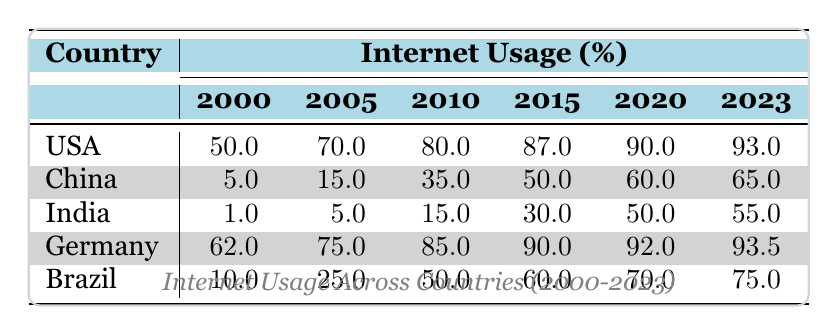What was the internet usage percentage in Germany in 2010? The table shows that in 2010, the internet usage in Germany was 85.0%.
Answer: 85.0 Which country had the highest internet usage in 2023? In 2023, the USA had the highest internet usage at 93.0%.
Answer: USA What is the difference in internet usage between India in 2000 and in 2023? India's internet usage in 2000 was 1.0%, and in 2023 it was 55.0%. The difference is 55.0 - 1.0 = 54.0%.
Answer: 54.0% Is it true that Brazil had more internet users than China in 2005? In 2005, Brazil had an internet usage of 25.0%, and China had 15.0%. Therefore, it is true that Brazil had more internet users than China in that year.
Answer: Yes What was the average internet usage across all countries in 2015? The internet usage values for all countries in 2015 are as follows: USA (87.0), China (50.0), India (30.0), Germany (90.0), and Brazil (60.0). The sum of these values is 87.0 + 50.0 + 30.0 + 90.0 + 60.0 = 317.0. Dividing by the number of countries (5) gives us an average of 317.0 / 5 = 63.4.
Answer: 63.4 How much did internet usage grow in China from 2000 to 2020? In 2000, China's internet usage was 5.0%, and by 2020 it had reached 60.0%. The growth is calculated as 60.0 - 5.0 = 55.0%.
Answer: 55.0% 